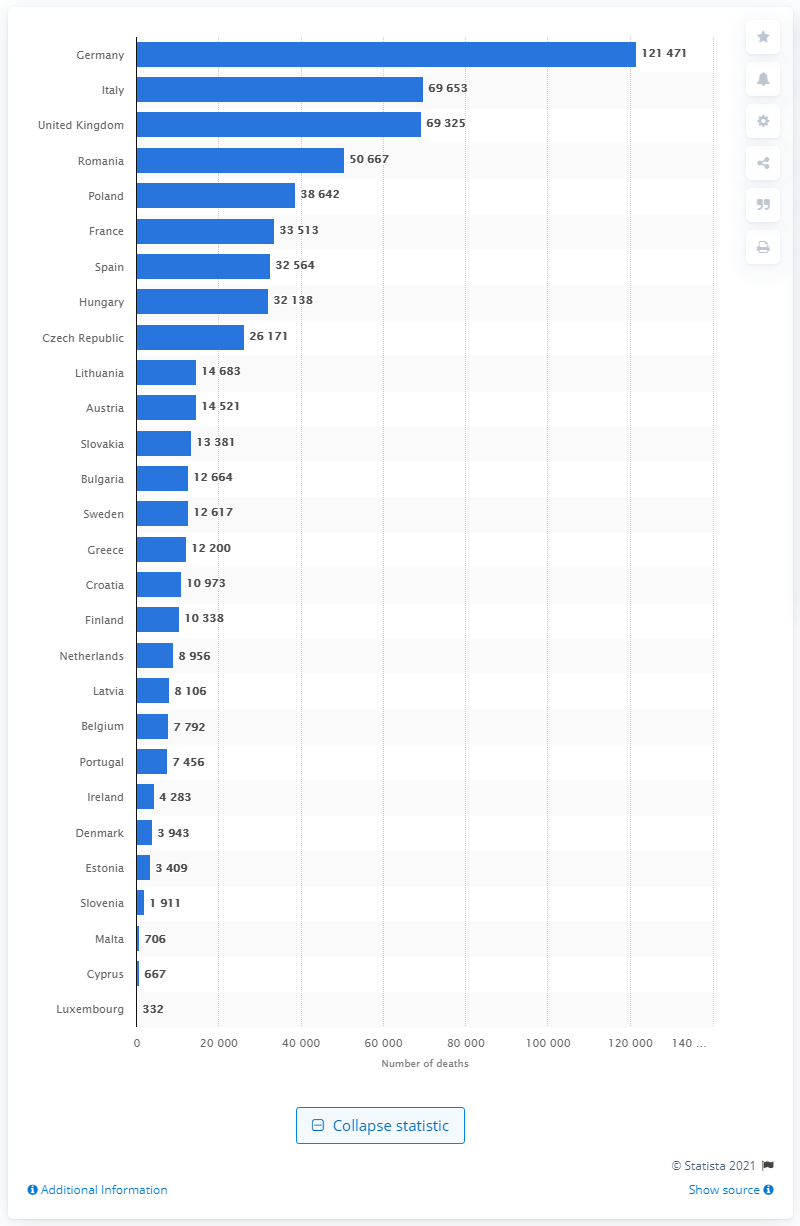Mention a couple of crucial points in this snapshot. Italy had the highest number of deaths due to heart attacks in 2014. 